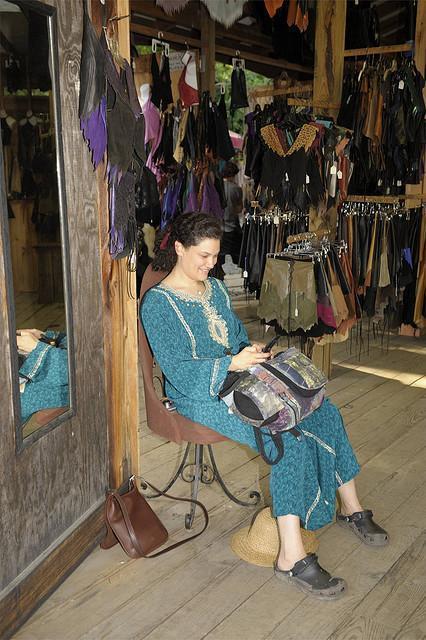What's the lady doing?
From the following set of four choices, select the accurate answer to respond to the question.
Options: Eating, reading, texting, playing. Texting. 